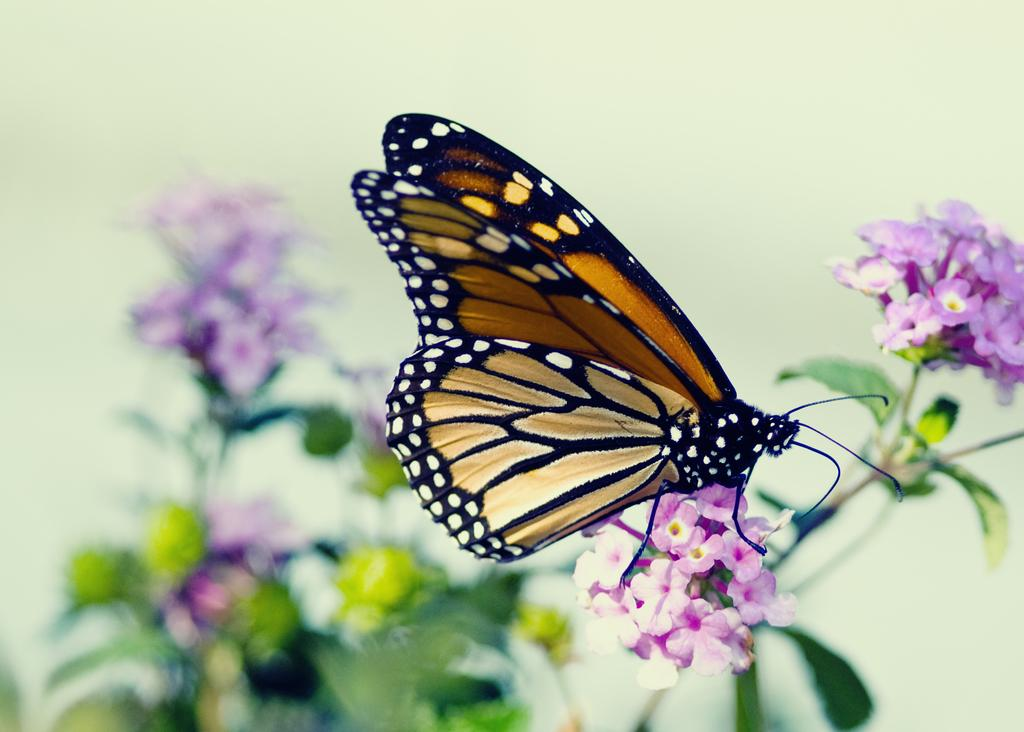What is the main subject of the image? There is a butterfly in the image. Where is the butterfly located? The butterfly is on the flowers. Can you describe the background of the image? The background of the image has a blurred view. What other elements can be seen in the image besides the butterfly? There are flowers, stems, and leaves in the image. Can you tell me how many kittens are playing near the airport in the image? There are no kittens or airports present in the image; it features a butterfly on flowers with a blurred background. What is the name of the daughter in the image? There is no daughter present in the image; it features a butterfly on flowers with a blurred background. 